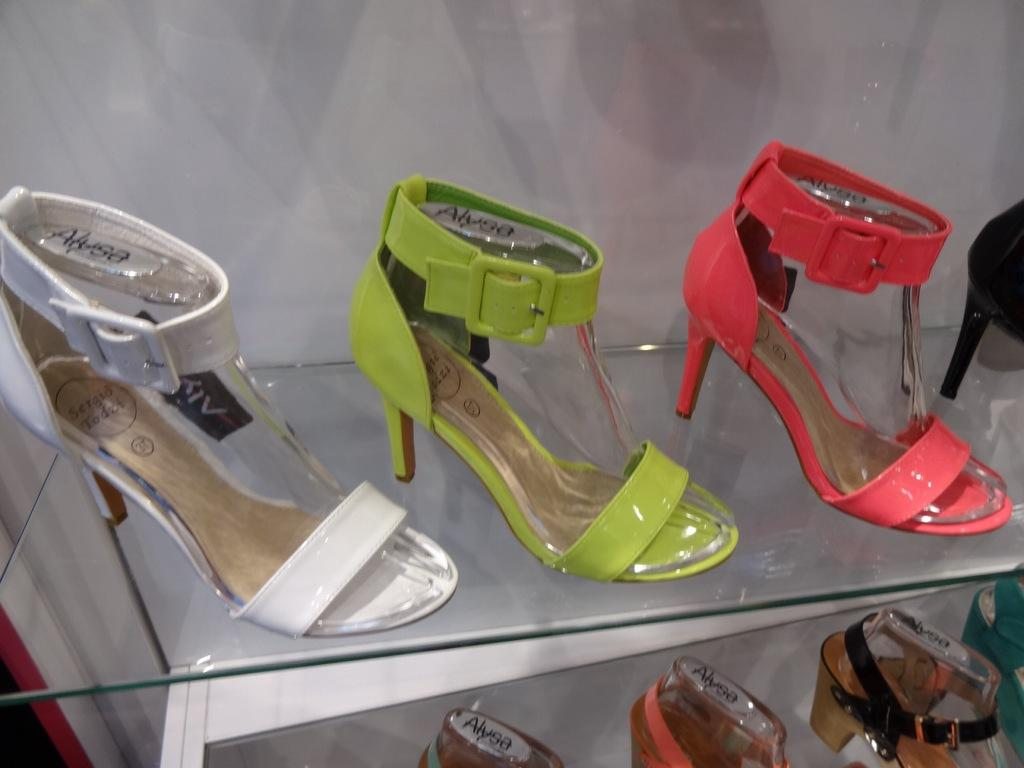Provide a one-sentence caption for the provided image. Many different brightly colored Alyssa high heels are displayed on a shelf. 